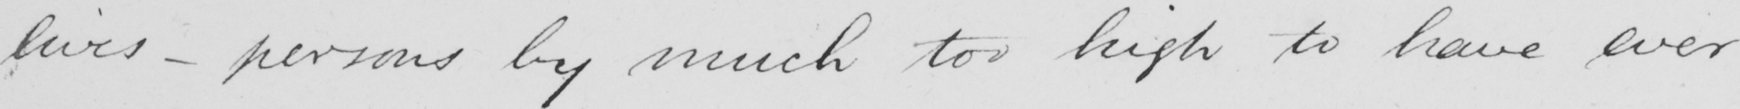Please provide the text content of this handwritten line. lives  _  persons by much too high to have ever 